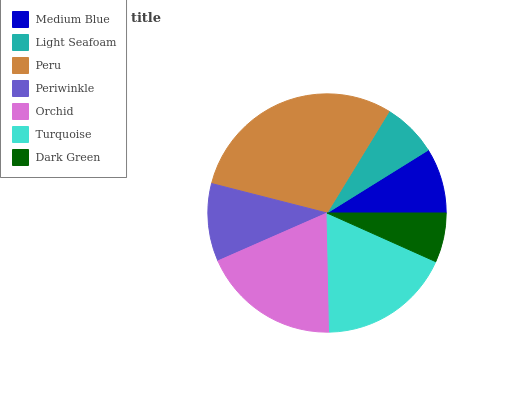Is Dark Green the minimum?
Answer yes or no. Yes. Is Peru the maximum?
Answer yes or no. Yes. Is Light Seafoam the minimum?
Answer yes or no. No. Is Light Seafoam the maximum?
Answer yes or no. No. Is Medium Blue greater than Light Seafoam?
Answer yes or no. Yes. Is Light Seafoam less than Medium Blue?
Answer yes or no. Yes. Is Light Seafoam greater than Medium Blue?
Answer yes or no. No. Is Medium Blue less than Light Seafoam?
Answer yes or no. No. Is Periwinkle the high median?
Answer yes or no. Yes. Is Periwinkle the low median?
Answer yes or no. Yes. Is Dark Green the high median?
Answer yes or no. No. Is Orchid the low median?
Answer yes or no. No. 